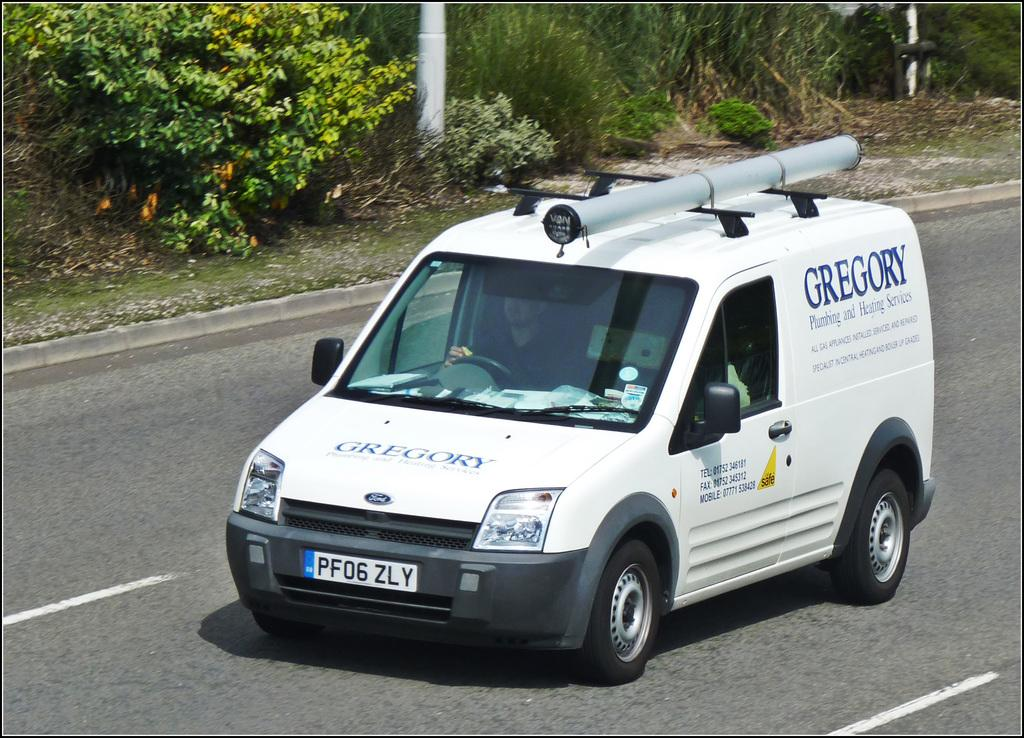What is the person in the image doing? The person in the image is driving a vehicle. Where is the vehicle located in the image? The vehicle is on the road. What type of vegetation can be seen in the image? There are plants and grass in the image. What other object can be seen in the image? There is a pole in the image. How much does the flower cost in the image? There is no flower present in the image, so it is not possible to determine its cost. 